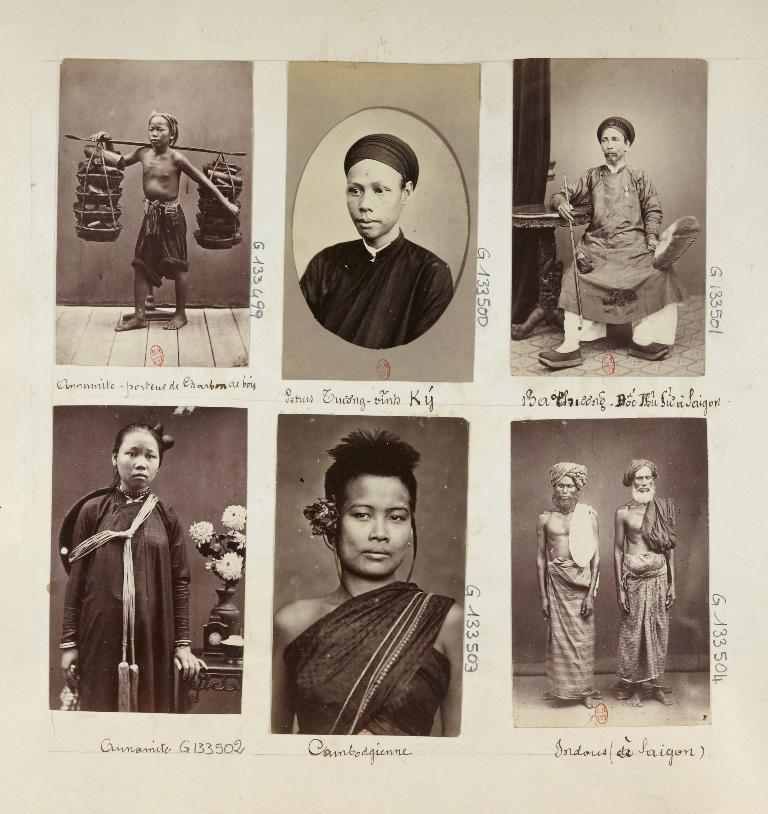What is the primary object in the image? There is a paper in the image. What can be found on the paper? The paper contains different human images and names associated with them. Are there any numerical elements in the image? Yes, there are numbers present in the image. How does the creator of the paper pull the images out of the paper? The image does not depict the process of pulling images out of the paper, nor does it show a creator. 